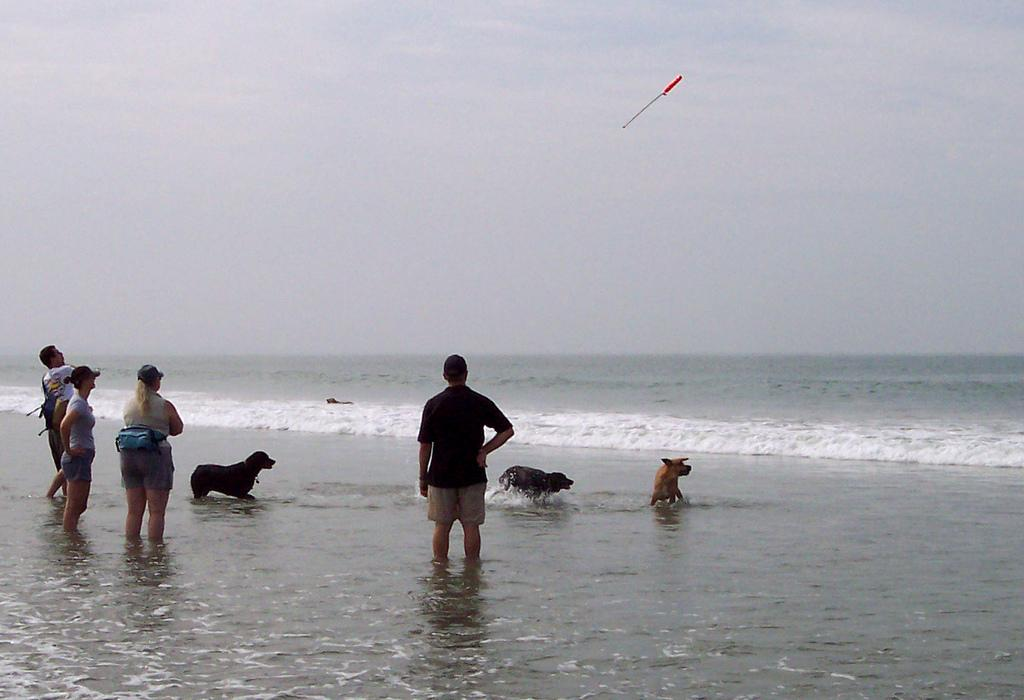Who or what can be seen in the image? There are persons and animals in the image. What are the persons and animals doing in the image? Both persons and animals are standing in the water. What can be seen in the background of the image? There is sky visible in the background of the image. What type of donkey is present in the image? There is no donkey present in the image; only persons and animals are mentioned. 